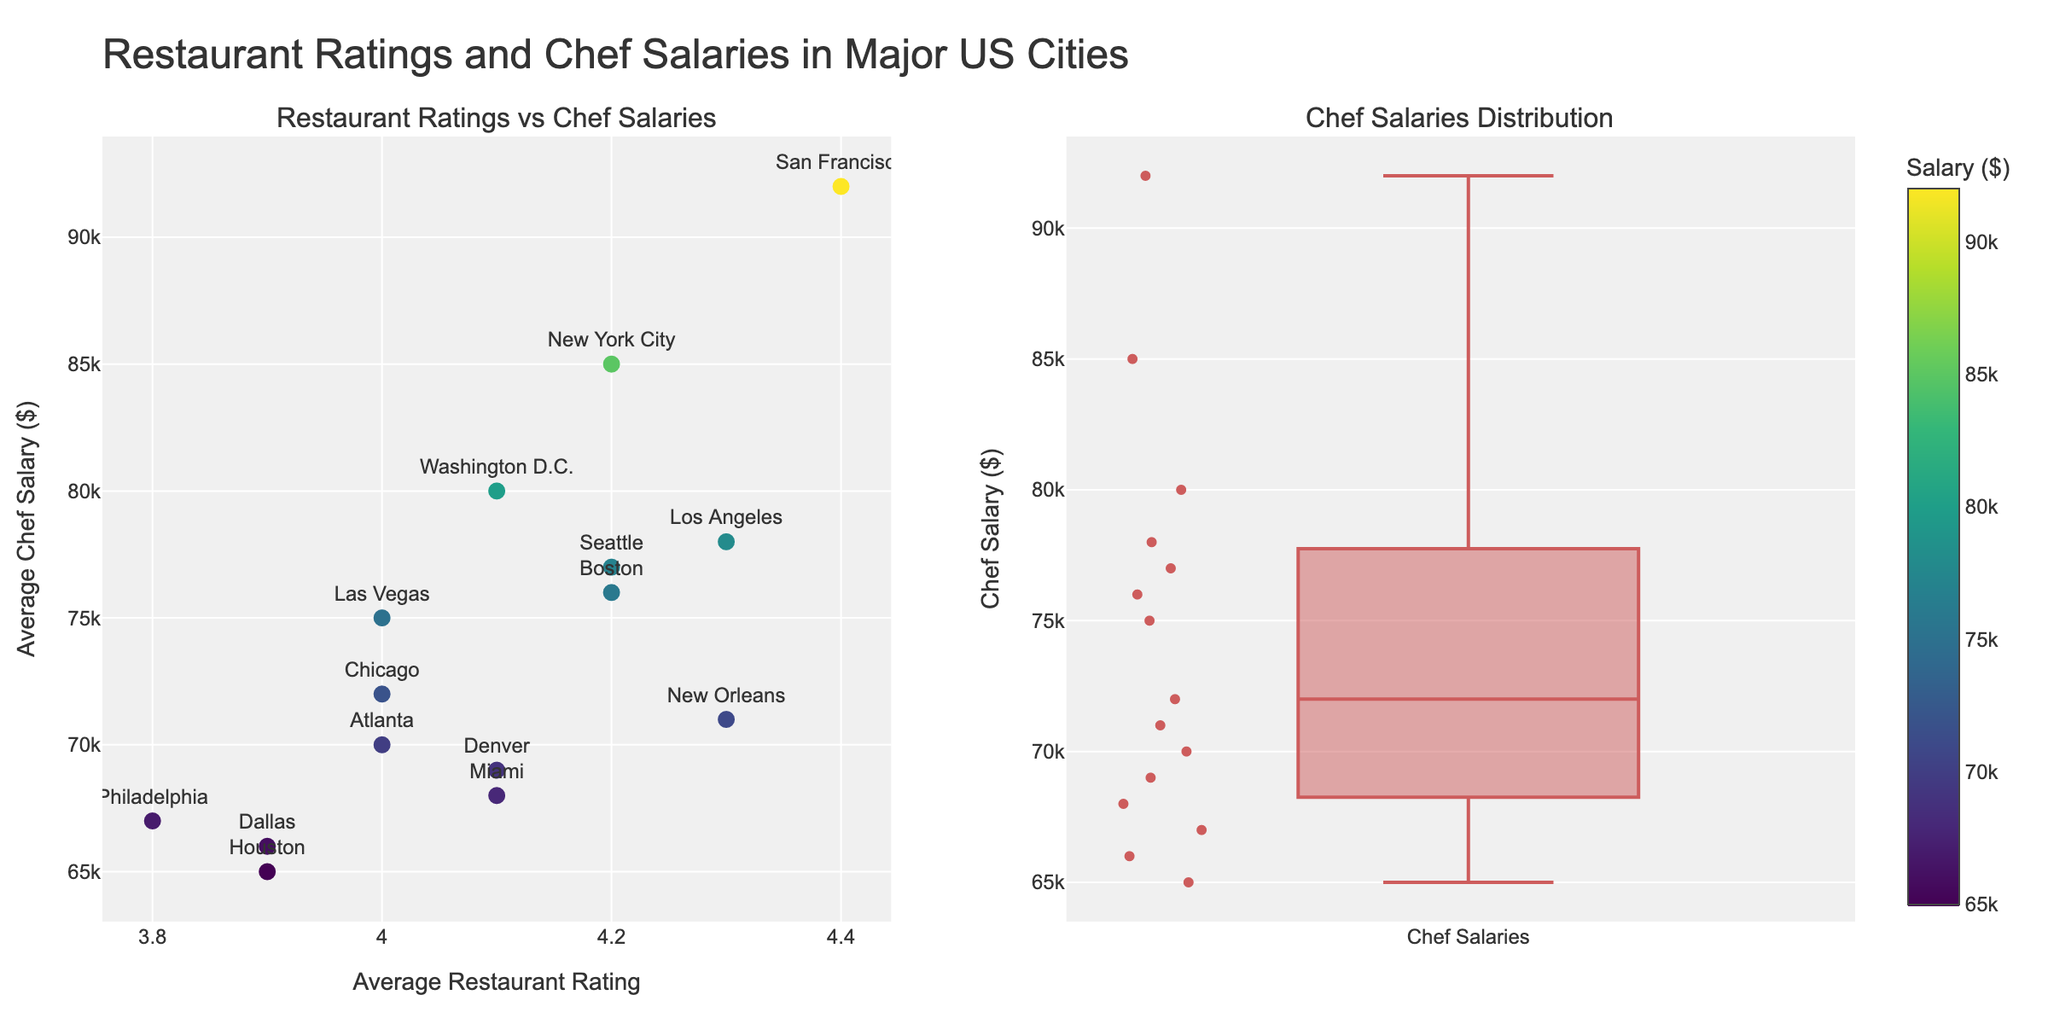What are the axes labels of the scatter plot on the left? The scatter plot on the left has its x-axis labeled as "Average Restaurant Rating" and its y-axis labeled as "Average Chef Salary ($)".
Answer: Average Restaurant Rating, Average Chef Salary ($) Which city has the highest average chef salary? San Francisco has the highest average chef salary of $92,000, as seen by hovering over the corresponding data point in the scatter plot.
Answer: San Francisco How many cities have an average restaurant rating of 4.0? By observing the scatter plot, we see that there are three cities with an average restaurant rating of 4.0: Chicago, Atlanta, and Las Vegas.
Answer: 3 What is the range of average chef salaries depicted in the box plot? The box plot on the right shows a range of chef salaries from approximately $65,000 to $92,000.
Answer: $65,000 to $92,000 Which city has a higher average chef salary: Los Angeles or Miami? Los Angeles has an average chef salary of $78,000, while Miami's average chef salary is $68,000. Therefore, Los Angeles has a higher average chef salary than Miami.
Answer: Los Angeles Is there a positive correlation between restaurant ratings and chef salaries? By observing the scatter plot, we can see that there is a general upward trend, suggesting a positive correlation between higher restaurant ratings and higher chef salaries.
Answer: Yes What’s the median average chef salary according to the box plot? The median value in the box plot is represented by the line inside the box, which is approximately $72,000.
Answer: $72,000 How many cities have average chef salaries exceeding $80,000? By observing the scatter plot, we see that three cities — New York City, San Francisco, and Washington D.C. — have average chef salaries exceeding $80,000.
Answer: 3 Which city has the lowest average restaurant rating? Philadelphia has the lowest average restaurant rating of 3.8, as seen by hovering over the corresponding data point in the scatter plot.
Answer: Philadelphia 